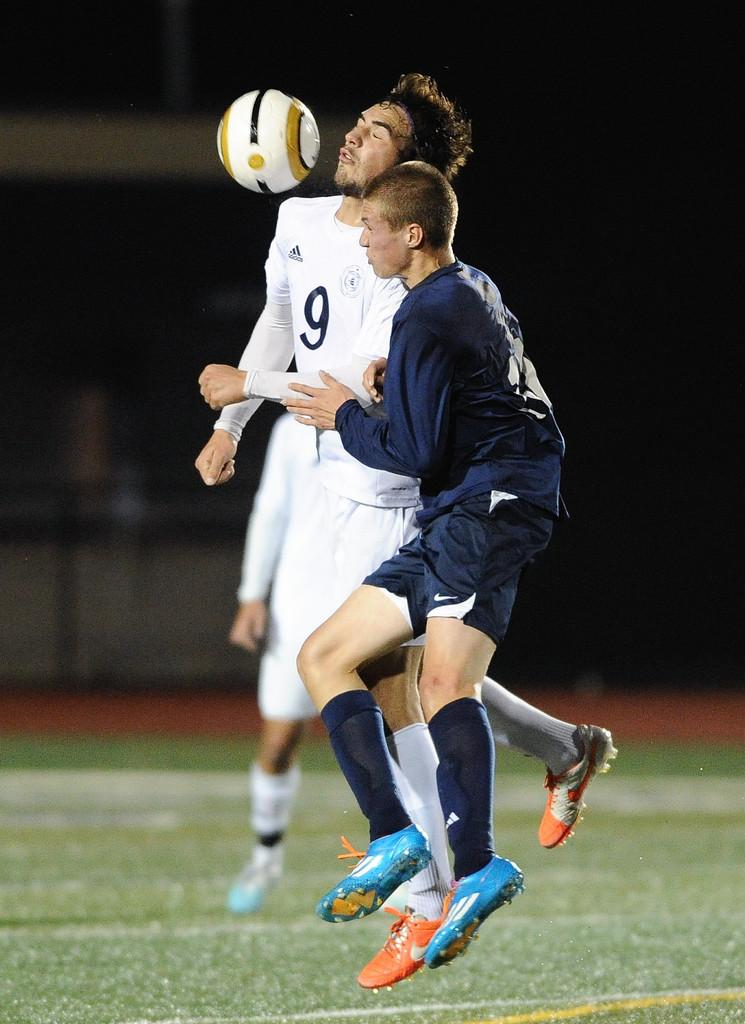<image>
Write a terse but informative summary of the picture. Man wearing a white number 9 jersey getting hit in the face. 